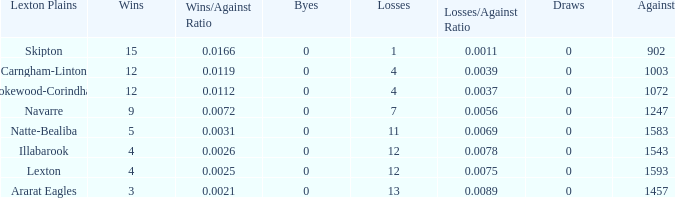What team has fewer than 9 wins and less than 1593 against? Natte-Bealiba, Illabarook, Ararat Eagles. 